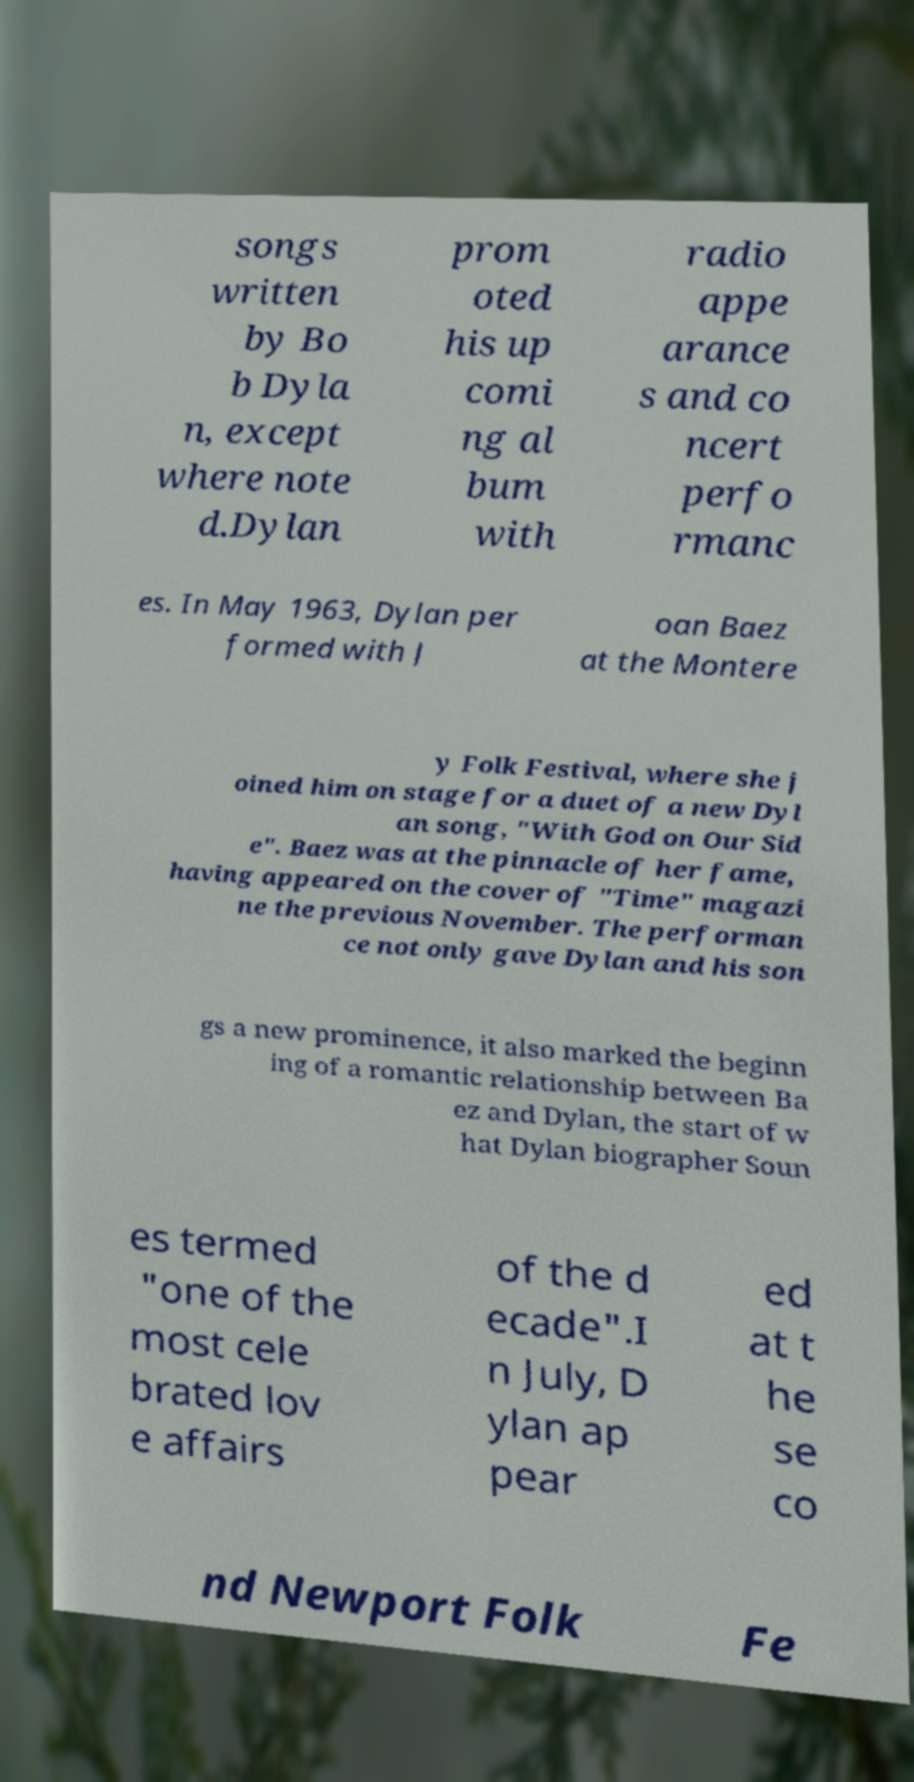Please identify and transcribe the text found in this image. songs written by Bo b Dyla n, except where note d.Dylan prom oted his up comi ng al bum with radio appe arance s and co ncert perfo rmanc es. In May 1963, Dylan per formed with J oan Baez at the Montere y Folk Festival, where she j oined him on stage for a duet of a new Dyl an song, "With God on Our Sid e". Baez was at the pinnacle of her fame, having appeared on the cover of "Time" magazi ne the previous November. The performan ce not only gave Dylan and his son gs a new prominence, it also marked the beginn ing of a romantic relationship between Ba ez and Dylan, the start of w hat Dylan biographer Soun es termed "one of the most cele brated lov e affairs of the d ecade".I n July, D ylan ap pear ed at t he se co nd Newport Folk Fe 